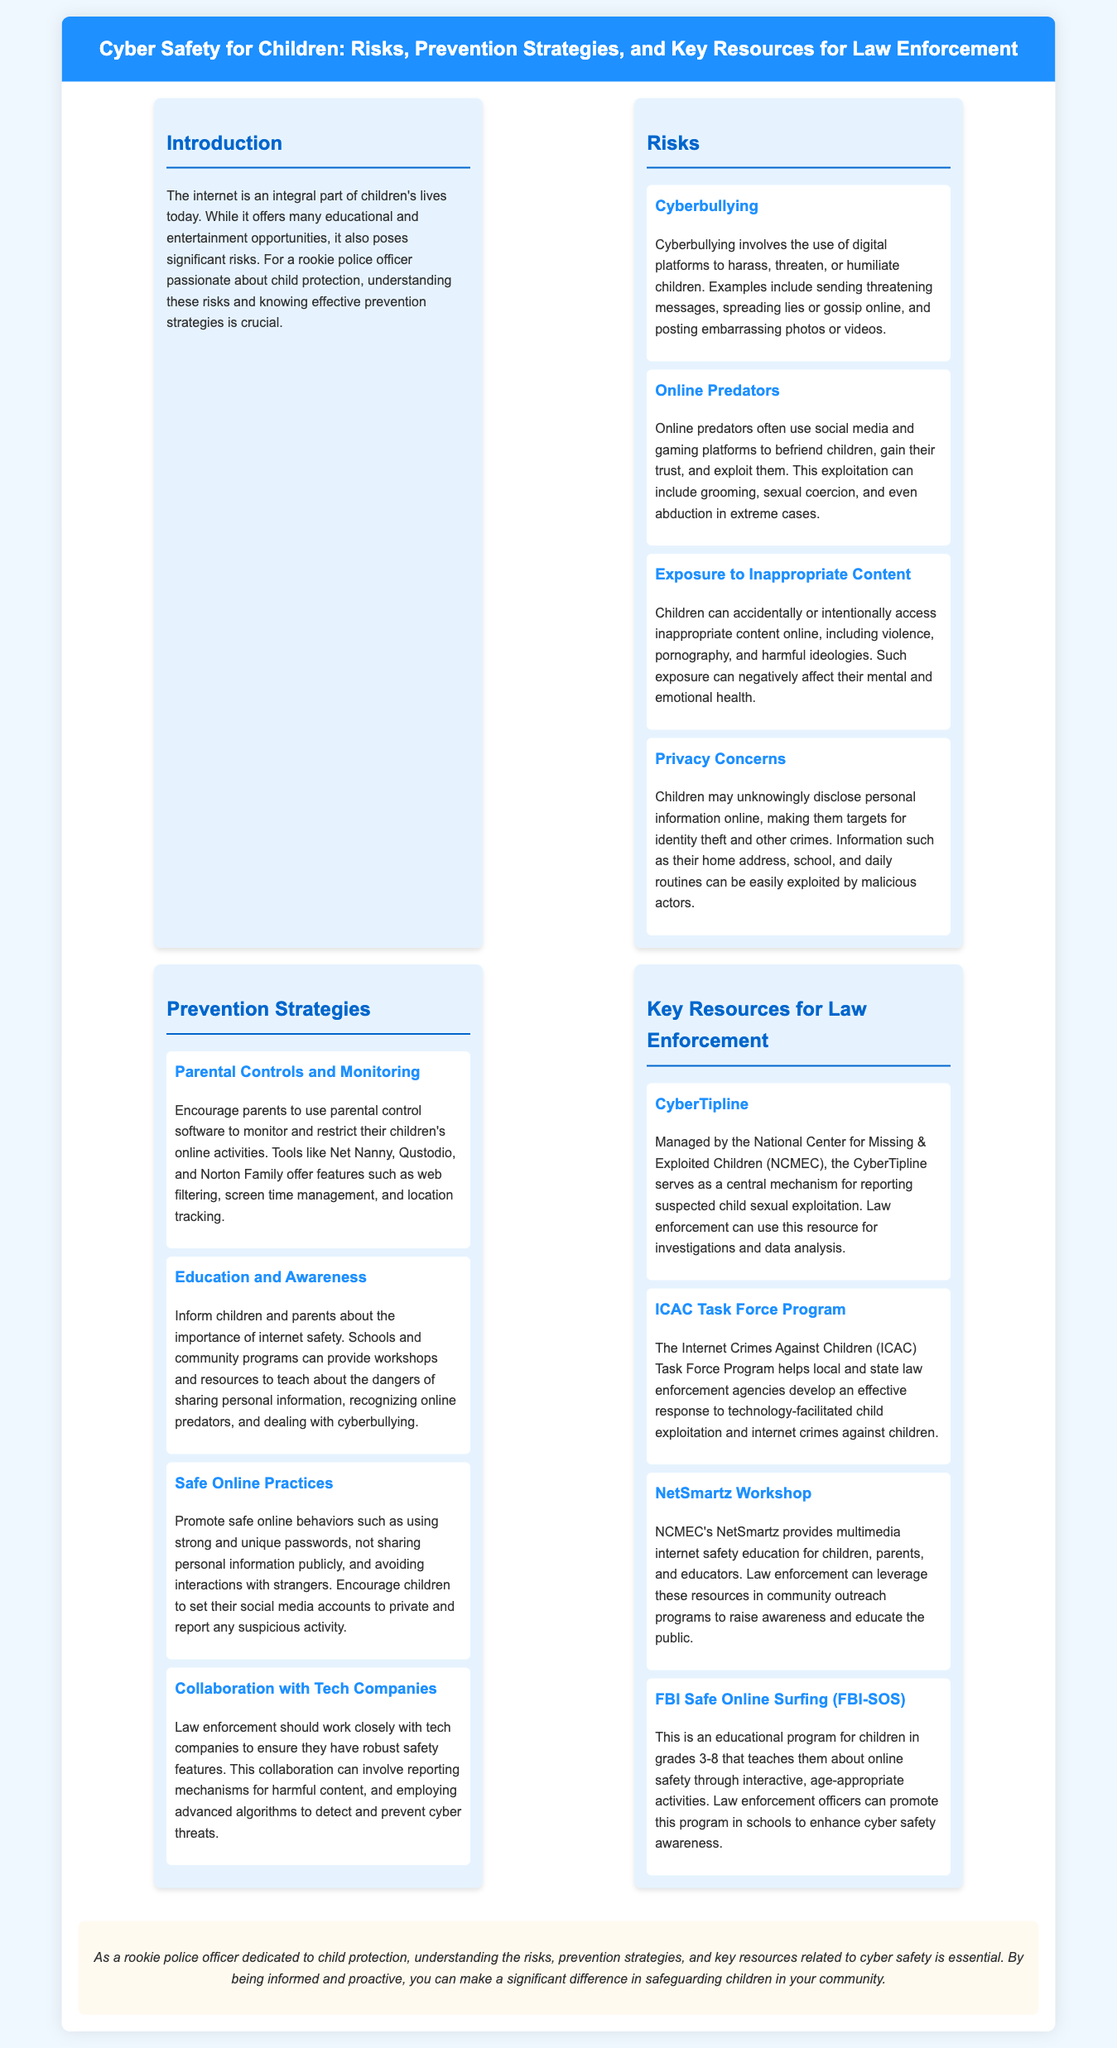What is the main topic of the infographic? The main topic is about cyber safety for children, emphasizing risks, prevention strategies, and key resources for law enforcement.
Answer: Cyber Safety for Children What is one example of cyberbullying? The document mentions sending threatening messages as an example of cyberbullying.
Answer: Sending threatening messages What are online predators known for? Online predators are known for exploiting children by befriending them online and gaining their trust.
Answer: Exploiting children Which organization manages the CyberTipline? The National Center for Missing & Exploited Children (NCMEC) manages the CyberTipline.
Answer: NCMEC What is a recommended tool for parental controls? The document suggests tools like Net Nanny for parental control.
Answer: Net Nanny What educational program does the FBI offer for children? The FBI offers the Safe Online Surfing (FBI-SOS) program for children.
Answer: FBI-SOS What is a major strategy to promote internet safety? Educating children and parents about internet safety is a major strategy mentioned.
Answer: Education and Awareness How do law enforcement agencies collaborate with tech companies? Law enforcement should work closely with tech companies to ensure robust safety features.
Answer: Collaboration for safety features 